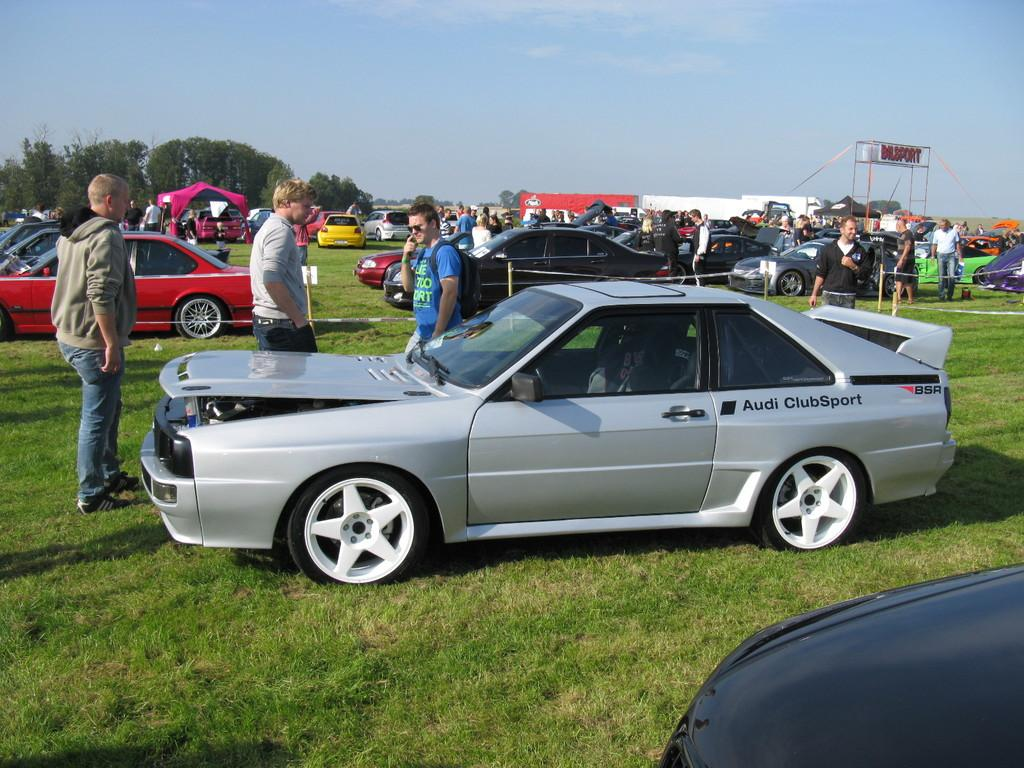What can be seen in large numbers in the image? There are many cars in the image. Who or what else is present in the image besides the cars? There are people, trees, tents, and banners in the image. What is the surface that the cars, people, trees, tents, and banners are on or near? The ground is visible at the bottom of the image. What type of soup is being served in the image? There is no soup present in the image. What type of apparel are the people wearing in the image? The provided facts do not mention the apparel of the people in the image. 